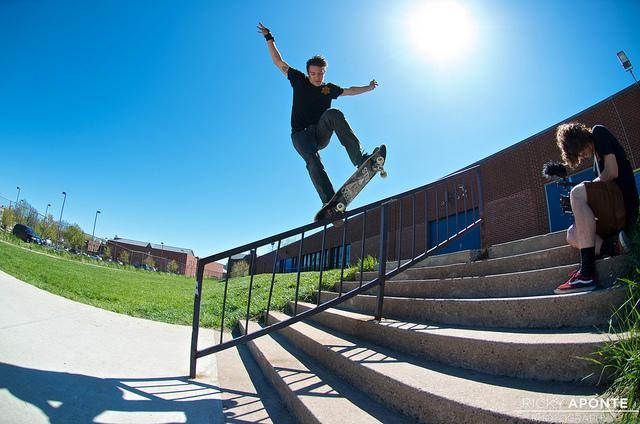Why is there a bright circle? sun 